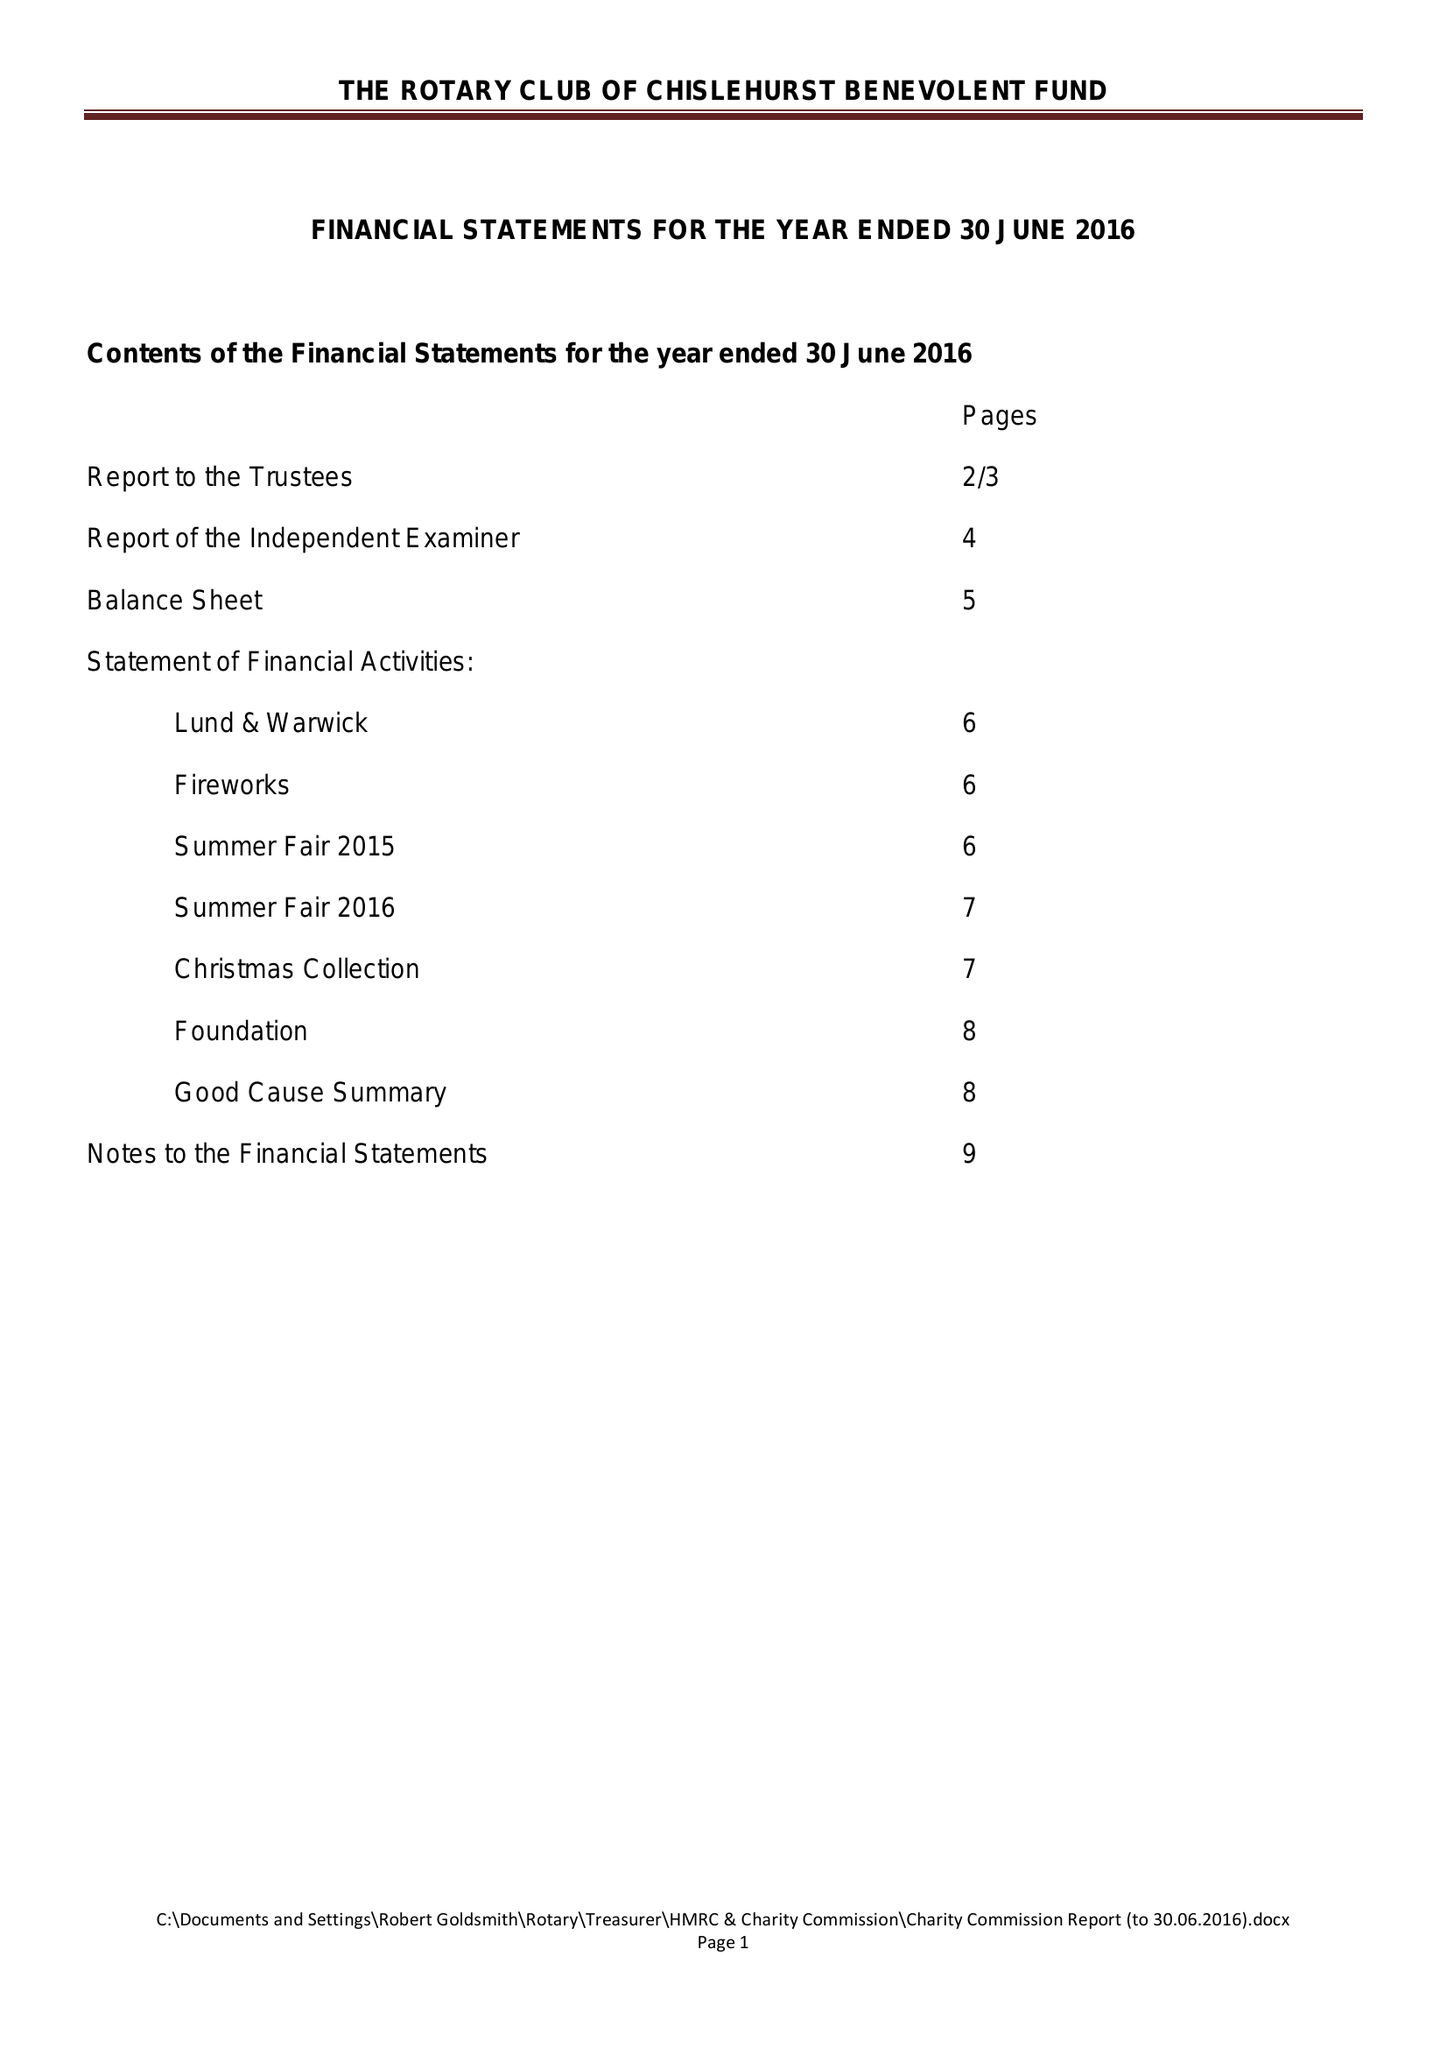What is the value for the spending_annually_in_british_pounds?
Answer the question using a single word or phrase. 30406.00 